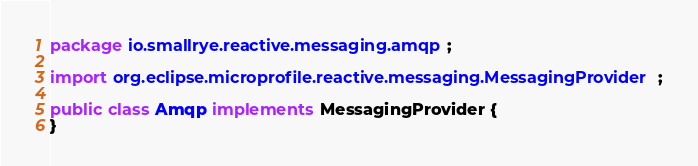<code> <loc_0><loc_0><loc_500><loc_500><_Java_>package io.smallrye.reactive.messaging.amqp;

import org.eclipse.microprofile.reactive.messaging.MessagingProvider;

public class Amqp implements MessagingProvider {
}
</code> 